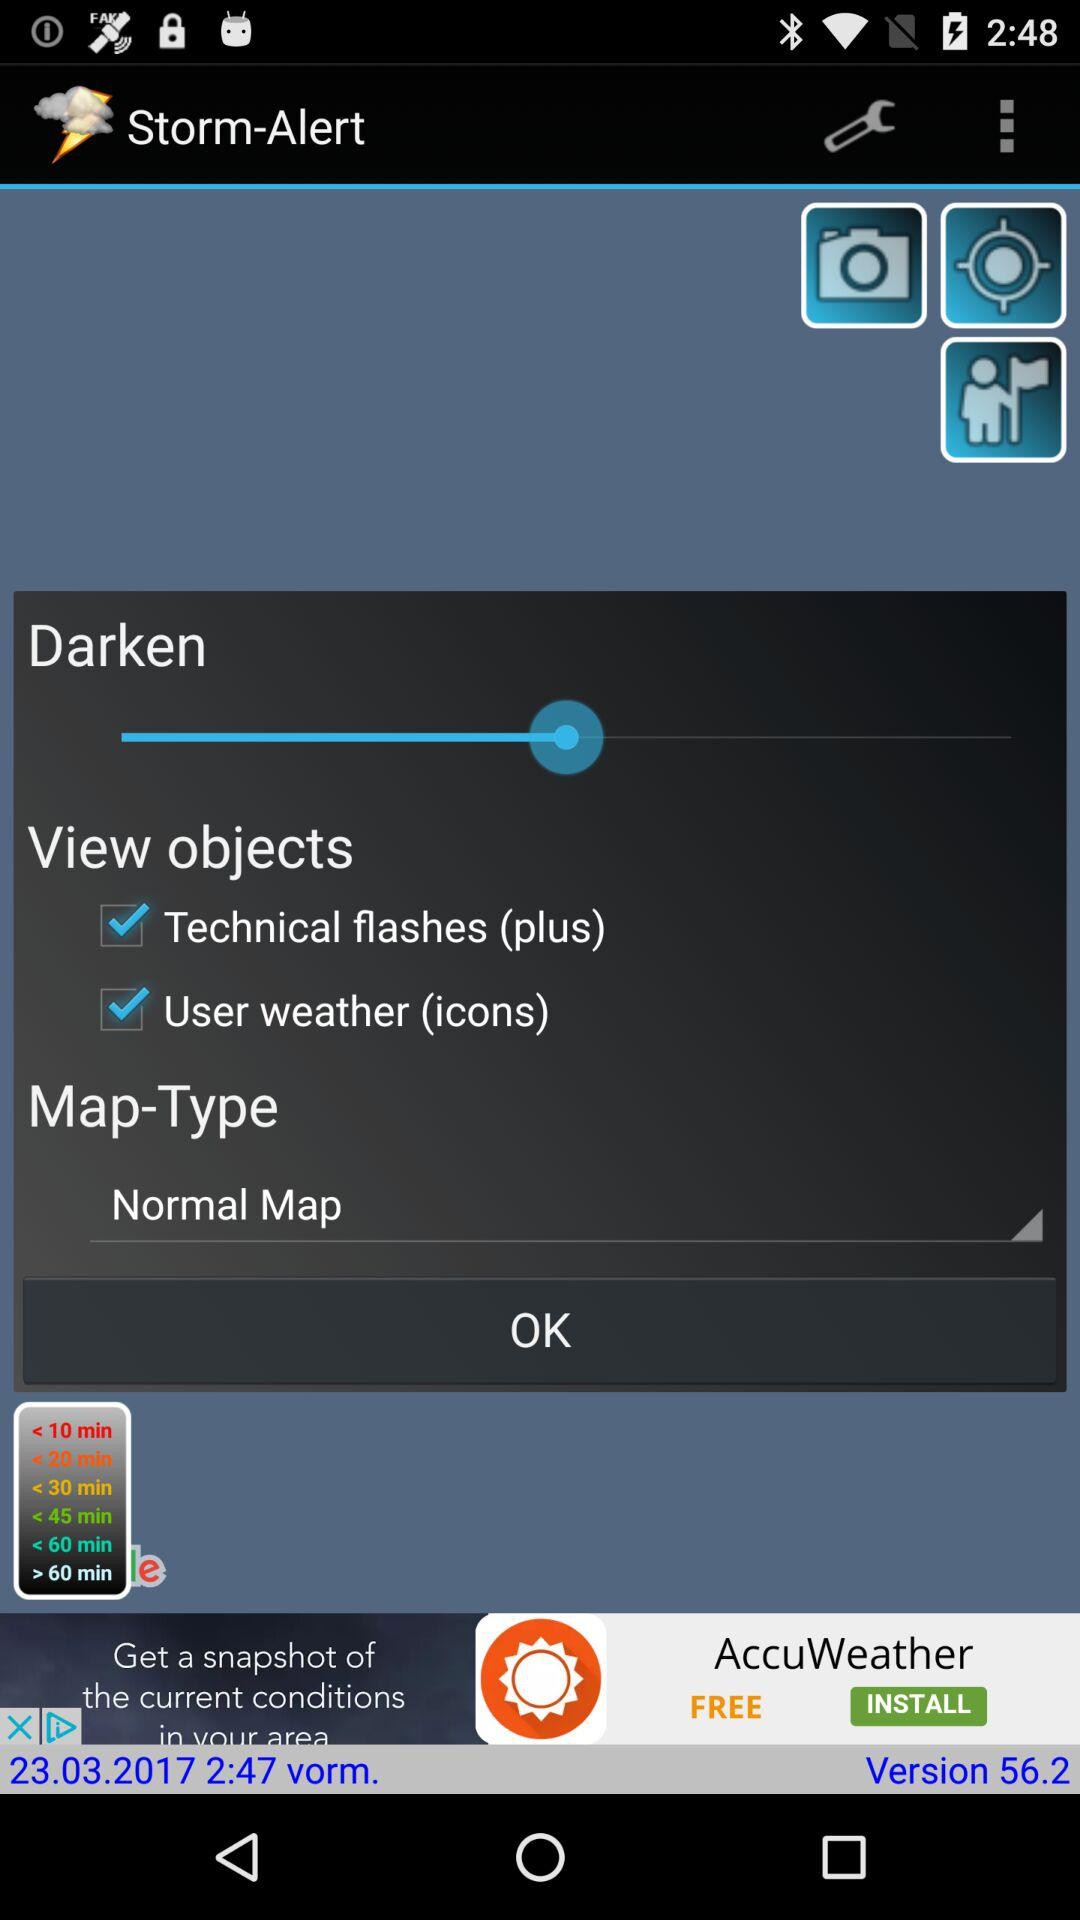What option is selected in "View objects"? The selected options are "Technical flashes (plus)" and "User weather (icons)". 